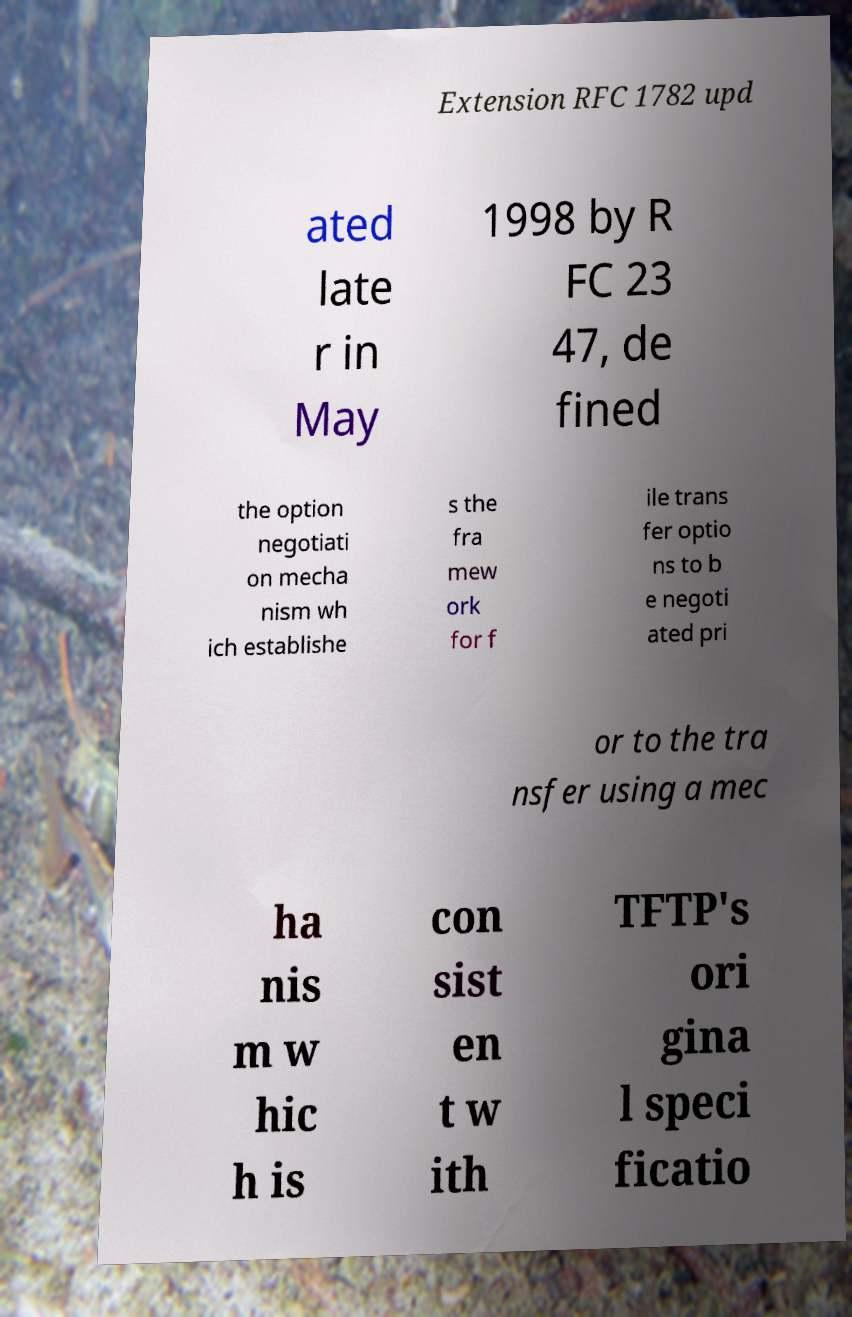Could you assist in decoding the text presented in this image and type it out clearly? Extension RFC 1782 upd ated late r in May 1998 by R FC 23 47, de fined the option negotiati on mecha nism wh ich establishe s the fra mew ork for f ile trans fer optio ns to b e negoti ated pri or to the tra nsfer using a mec ha nis m w hic h is con sist en t w ith TFTP's ori gina l speci ficatio 